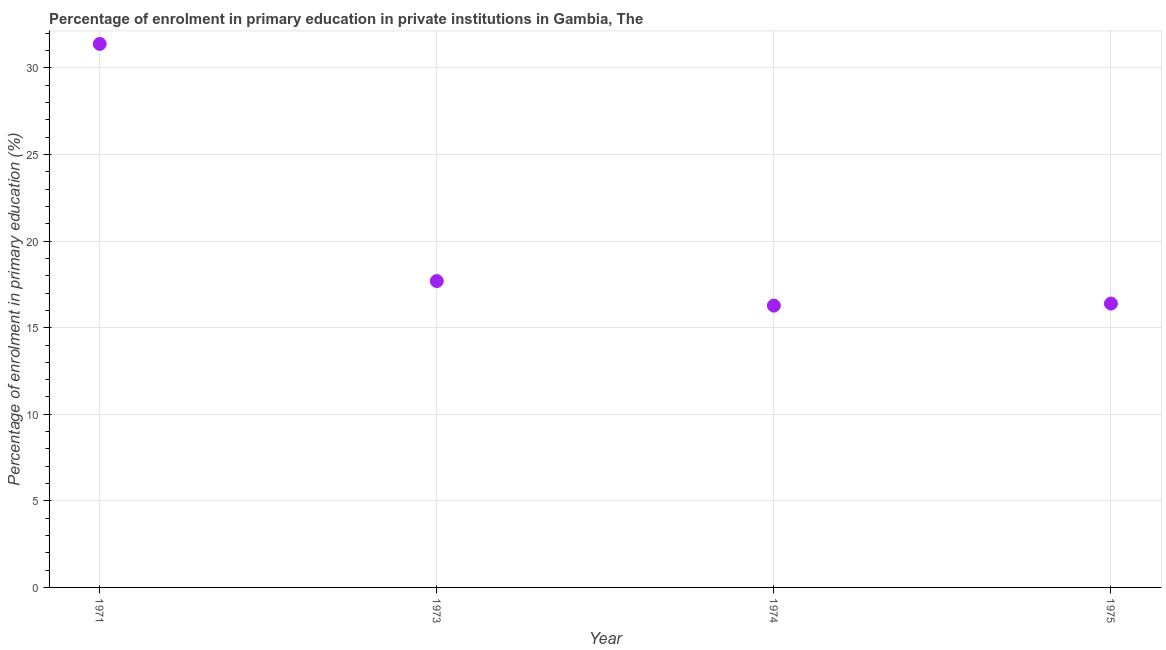What is the enrolment percentage in primary education in 1971?
Your answer should be very brief. 31.39. Across all years, what is the maximum enrolment percentage in primary education?
Offer a terse response. 31.39. Across all years, what is the minimum enrolment percentage in primary education?
Ensure brevity in your answer.  16.28. In which year was the enrolment percentage in primary education maximum?
Provide a succinct answer. 1971. In which year was the enrolment percentage in primary education minimum?
Your answer should be compact. 1974. What is the sum of the enrolment percentage in primary education?
Your answer should be very brief. 81.75. What is the difference between the enrolment percentage in primary education in 1971 and 1973?
Provide a short and direct response. 13.7. What is the average enrolment percentage in primary education per year?
Keep it short and to the point. 20.44. What is the median enrolment percentage in primary education?
Give a very brief answer. 17.04. What is the ratio of the enrolment percentage in primary education in 1973 to that in 1974?
Offer a very short reply. 1.09. Is the difference between the enrolment percentage in primary education in 1971 and 1973 greater than the difference between any two years?
Ensure brevity in your answer.  No. What is the difference between the highest and the second highest enrolment percentage in primary education?
Offer a terse response. 13.7. What is the difference between the highest and the lowest enrolment percentage in primary education?
Provide a succinct answer. 15.11. In how many years, is the enrolment percentage in primary education greater than the average enrolment percentage in primary education taken over all years?
Ensure brevity in your answer.  1. Does the enrolment percentage in primary education monotonically increase over the years?
Keep it short and to the point. No. How many dotlines are there?
Offer a terse response. 1. How many years are there in the graph?
Provide a succinct answer. 4. Are the values on the major ticks of Y-axis written in scientific E-notation?
Offer a very short reply. No. Does the graph contain any zero values?
Make the answer very short. No. Does the graph contain grids?
Ensure brevity in your answer.  Yes. What is the title of the graph?
Your response must be concise. Percentage of enrolment in primary education in private institutions in Gambia, The. What is the label or title of the Y-axis?
Offer a terse response. Percentage of enrolment in primary education (%). What is the Percentage of enrolment in primary education (%) in 1971?
Give a very brief answer. 31.39. What is the Percentage of enrolment in primary education (%) in 1973?
Make the answer very short. 17.69. What is the Percentage of enrolment in primary education (%) in 1974?
Give a very brief answer. 16.28. What is the Percentage of enrolment in primary education (%) in 1975?
Make the answer very short. 16.39. What is the difference between the Percentage of enrolment in primary education (%) in 1971 and 1973?
Provide a succinct answer. 13.7. What is the difference between the Percentage of enrolment in primary education (%) in 1971 and 1974?
Offer a terse response. 15.11. What is the difference between the Percentage of enrolment in primary education (%) in 1971 and 1975?
Offer a very short reply. 15. What is the difference between the Percentage of enrolment in primary education (%) in 1973 and 1974?
Your answer should be very brief. 1.42. What is the difference between the Percentage of enrolment in primary education (%) in 1973 and 1975?
Offer a terse response. 1.3. What is the difference between the Percentage of enrolment in primary education (%) in 1974 and 1975?
Provide a short and direct response. -0.12. What is the ratio of the Percentage of enrolment in primary education (%) in 1971 to that in 1973?
Offer a terse response. 1.77. What is the ratio of the Percentage of enrolment in primary education (%) in 1971 to that in 1974?
Provide a short and direct response. 1.93. What is the ratio of the Percentage of enrolment in primary education (%) in 1971 to that in 1975?
Your response must be concise. 1.92. What is the ratio of the Percentage of enrolment in primary education (%) in 1973 to that in 1974?
Ensure brevity in your answer.  1.09. What is the ratio of the Percentage of enrolment in primary education (%) in 1973 to that in 1975?
Offer a very short reply. 1.08. What is the ratio of the Percentage of enrolment in primary education (%) in 1974 to that in 1975?
Provide a succinct answer. 0.99. 